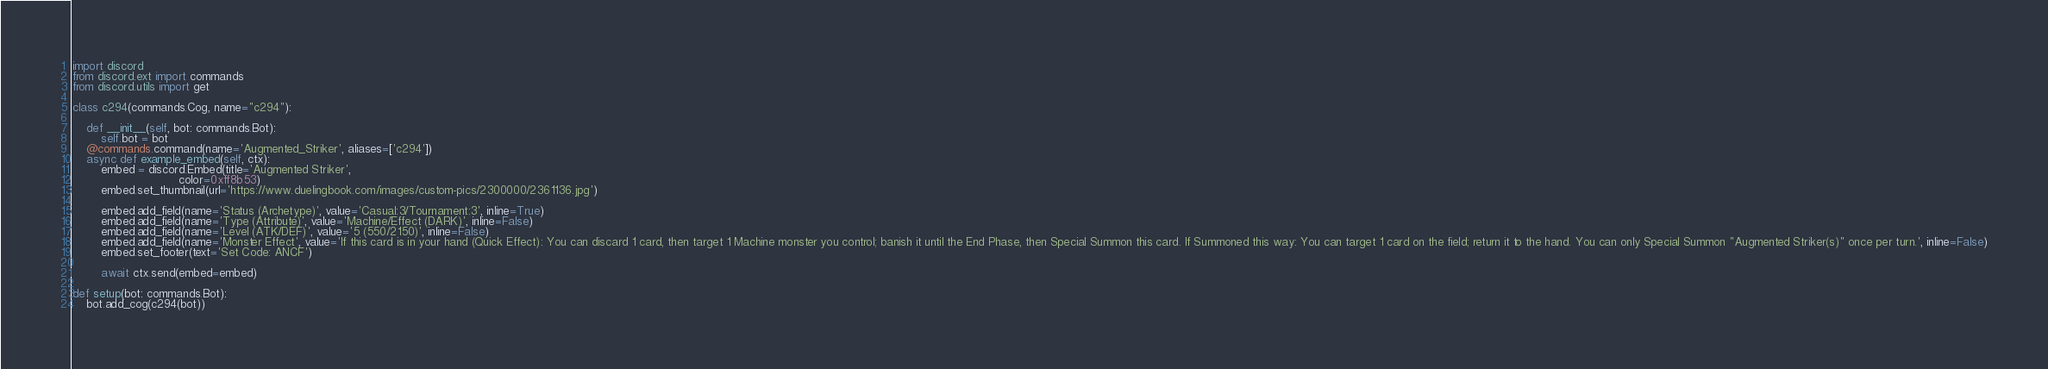Convert code to text. <code><loc_0><loc_0><loc_500><loc_500><_Python_>import discord
from discord.ext import commands
from discord.utils import get

class c294(commands.Cog, name="c294"):

    def __init__(self, bot: commands.Bot):
        self.bot = bot
    @commands.command(name='Augmented_Striker', aliases=['c294'])
    async def example_embed(self, ctx):
        embed = discord.Embed(title='Augmented Striker',
                              color=0xff8b53)
        embed.set_thumbnail(url='https://www.duelingbook.com/images/custom-pics/2300000/2361136.jpg')

        embed.add_field(name='Status (Archetype)', value='Casual:3/Tournament:3', inline=True)
        embed.add_field(name='Type (Attribute)', value='Machine/Effect (DARK)', inline=False)
        embed.add_field(name='Level (ATK/DEF)', value='5 (550/2150)', inline=False)
        embed.add_field(name='Monster Effect', value='If this card is in your hand (Quick Effect): You can discard 1 card, then target 1 Machine monster you control; banish it until the End Phase, then Special Summon this card. If Summoned this way: You can target 1 card on the field; return it to the hand. You can only Special Summon "Augmented Striker(s)" once per turn.', inline=False)
        embed.set_footer(text='Set Code: ANCF')

        await ctx.send(embed=embed)

def setup(bot: commands.Bot):
    bot.add_cog(c294(bot))</code> 